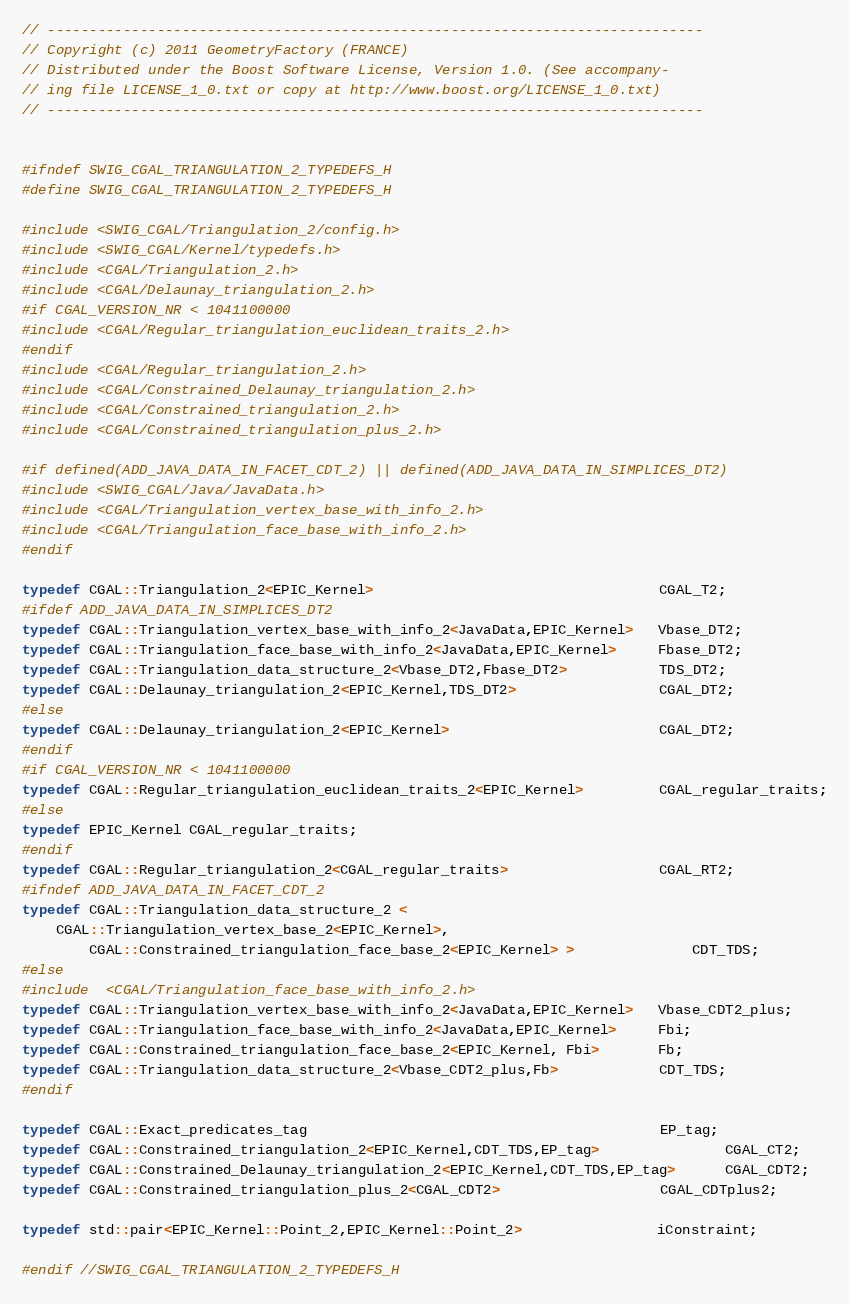Convert code to text. <code><loc_0><loc_0><loc_500><loc_500><_C_>// ------------------------------------------------------------------------------
// Copyright (c) 2011 GeometryFactory (FRANCE)
// Distributed under the Boost Software License, Version 1.0. (See accompany-
// ing file LICENSE_1_0.txt or copy at http://www.boost.org/LICENSE_1_0.txt)
// ------------------------------------------------------------------------------ 


#ifndef SWIG_CGAL_TRIANGULATION_2_TYPEDEFS_H
#define SWIG_CGAL_TRIANGULATION_2_TYPEDEFS_H

#include <SWIG_CGAL/Triangulation_2/config.h>
#include <SWIG_CGAL/Kernel/typedefs.h>
#include <CGAL/Triangulation_2.h>
#include <CGAL/Delaunay_triangulation_2.h>
#if CGAL_VERSION_NR < 1041100000
#include <CGAL/Regular_triangulation_euclidean_traits_2.h>
#endif
#include <CGAL/Regular_triangulation_2.h>
#include <CGAL/Constrained_Delaunay_triangulation_2.h>
#include <CGAL/Constrained_triangulation_2.h>
#include <CGAL/Constrained_triangulation_plus_2.h>  

#if defined(ADD_JAVA_DATA_IN_FACET_CDT_2) || defined(ADD_JAVA_DATA_IN_SIMPLICES_DT2)
#include <SWIG_CGAL/Java/JavaData.h>
#include <CGAL/Triangulation_vertex_base_with_info_2.h>
#include <CGAL/Triangulation_face_base_with_info_2.h>
#endif

typedef CGAL::Triangulation_2<EPIC_Kernel>                                  CGAL_T2;
#ifdef ADD_JAVA_DATA_IN_SIMPLICES_DT2
typedef CGAL::Triangulation_vertex_base_with_info_2<JavaData,EPIC_Kernel>   Vbase_DT2;
typedef CGAL::Triangulation_face_base_with_info_2<JavaData,EPIC_Kernel>     Fbase_DT2;
typedef CGAL::Triangulation_data_structure_2<Vbase_DT2,Fbase_DT2>           TDS_DT2;
typedef CGAL::Delaunay_triangulation_2<EPIC_Kernel,TDS_DT2>                 CGAL_DT2;
#else
typedef CGAL::Delaunay_triangulation_2<EPIC_Kernel>                         CGAL_DT2;
#endif
#if CGAL_VERSION_NR < 1041100000
typedef CGAL::Regular_triangulation_euclidean_traits_2<EPIC_Kernel>         CGAL_regular_traits;
#else
typedef EPIC_Kernel CGAL_regular_traits;
#endif
typedef CGAL::Regular_triangulation_2<CGAL_regular_traits>                  CGAL_RT2;
#ifndef ADD_JAVA_DATA_IN_FACET_CDT_2
typedef CGAL::Triangulation_data_structure_2 <
    CGAL::Triangulation_vertex_base_2<EPIC_Kernel>,
		CGAL::Constrained_triangulation_face_base_2<EPIC_Kernel> >              CDT_TDS;
#else
#include  <CGAL/Triangulation_face_base_with_info_2.h>  
typedef CGAL::Triangulation_vertex_base_with_info_2<JavaData,EPIC_Kernel>   Vbase_CDT2_plus;
typedef CGAL::Triangulation_face_base_with_info_2<JavaData,EPIC_Kernel>     Fbi;
typedef CGAL::Constrained_triangulation_face_base_2<EPIC_Kernel, Fbi>       Fb;
typedef CGAL::Triangulation_data_structure_2<Vbase_CDT2_plus,Fb>            CDT_TDS;
#endif
   
typedef CGAL::Exact_predicates_tag                                          EP_tag;
typedef CGAL::Constrained_triangulation_2<EPIC_Kernel,CDT_TDS,EP_tag>               CGAL_CT2;
typedef CGAL::Constrained_Delaunay_triangulation_2<EPIC_Kernel,CDT_TDS,EP_tag>      CGAL_CDT2;
typedef CGAL::Constrained_triangulation_plus_2<CGAL_CDT2>                   CGAL_CDTplus2;

typedef std::pair<EPIC_Kernel::Point_2,EPIC_Kernel::Point_2>                iConstraint;

#endif //SWIG_CGAL_TRIANGULATION_2_TYPEDEFS_H
</code> 